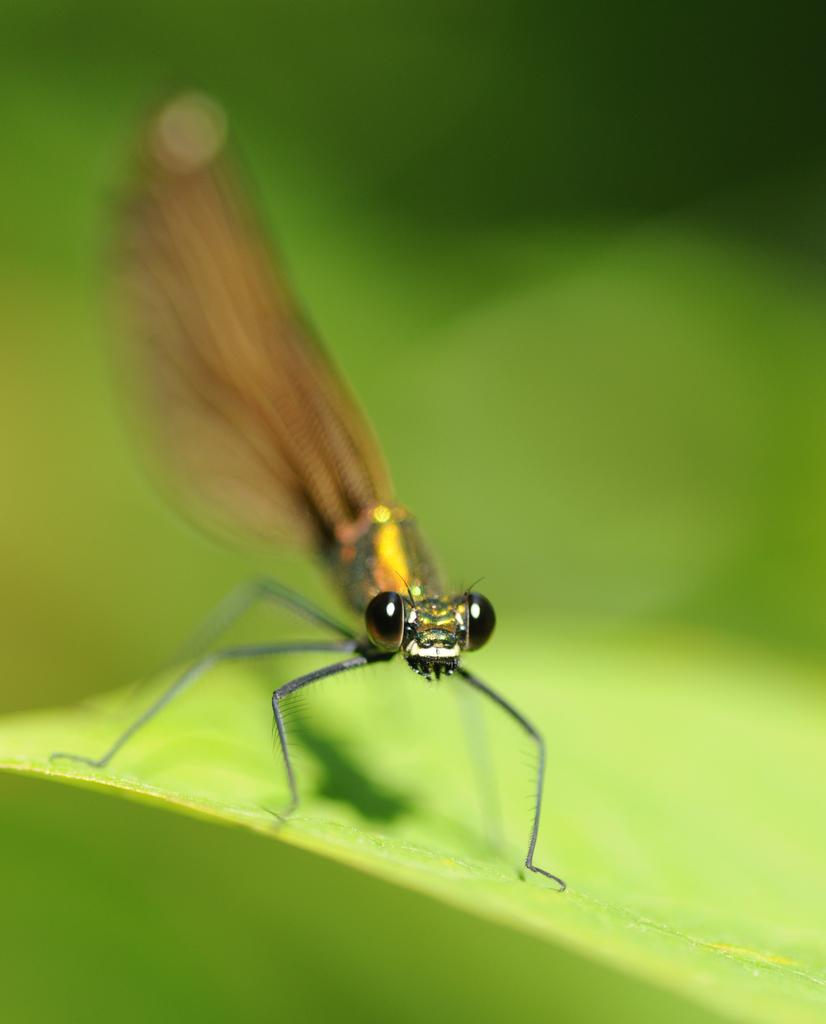What is the main subject of the picture? The main subject of the picture is an insect. What is the insect resting on? The insect is on a green object. How would you describe the background of the image? The background of the image is blurred. What type of curve can be seen in the image? There is no curve present in the image; it features an insect on a green object with a blurred background. 